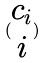<formula> <loc_0><loc_0><loc_500><loc_500>( \begin{matrix} c _ { i } \\ i \end{matrix} )</formula> 